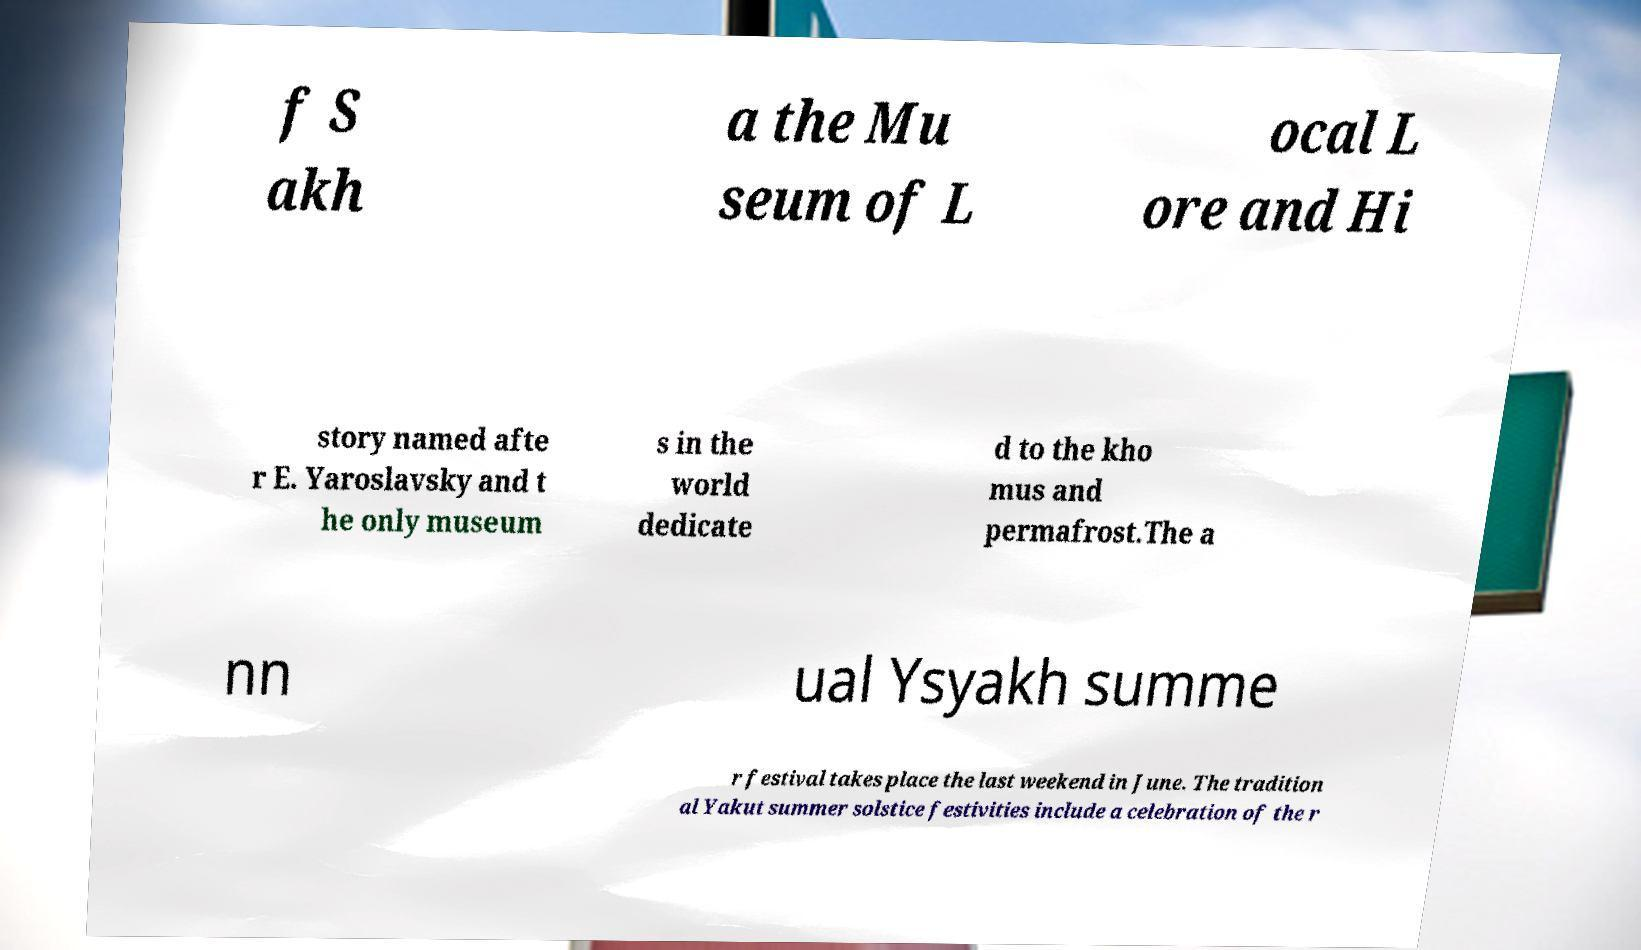Please identify and transcribe the text found in this image. f S akh a the Mu seum of L ocal L ore and Hi story named afte r E. Yaroslavsky and t he only museum s in the world dedicate d to the kho mus and permafrost.The a nn ual Ysyakh summe r festival takes place the last weekend in June. The tradition al Yakut summer solstice festivities include a celebration of the r 